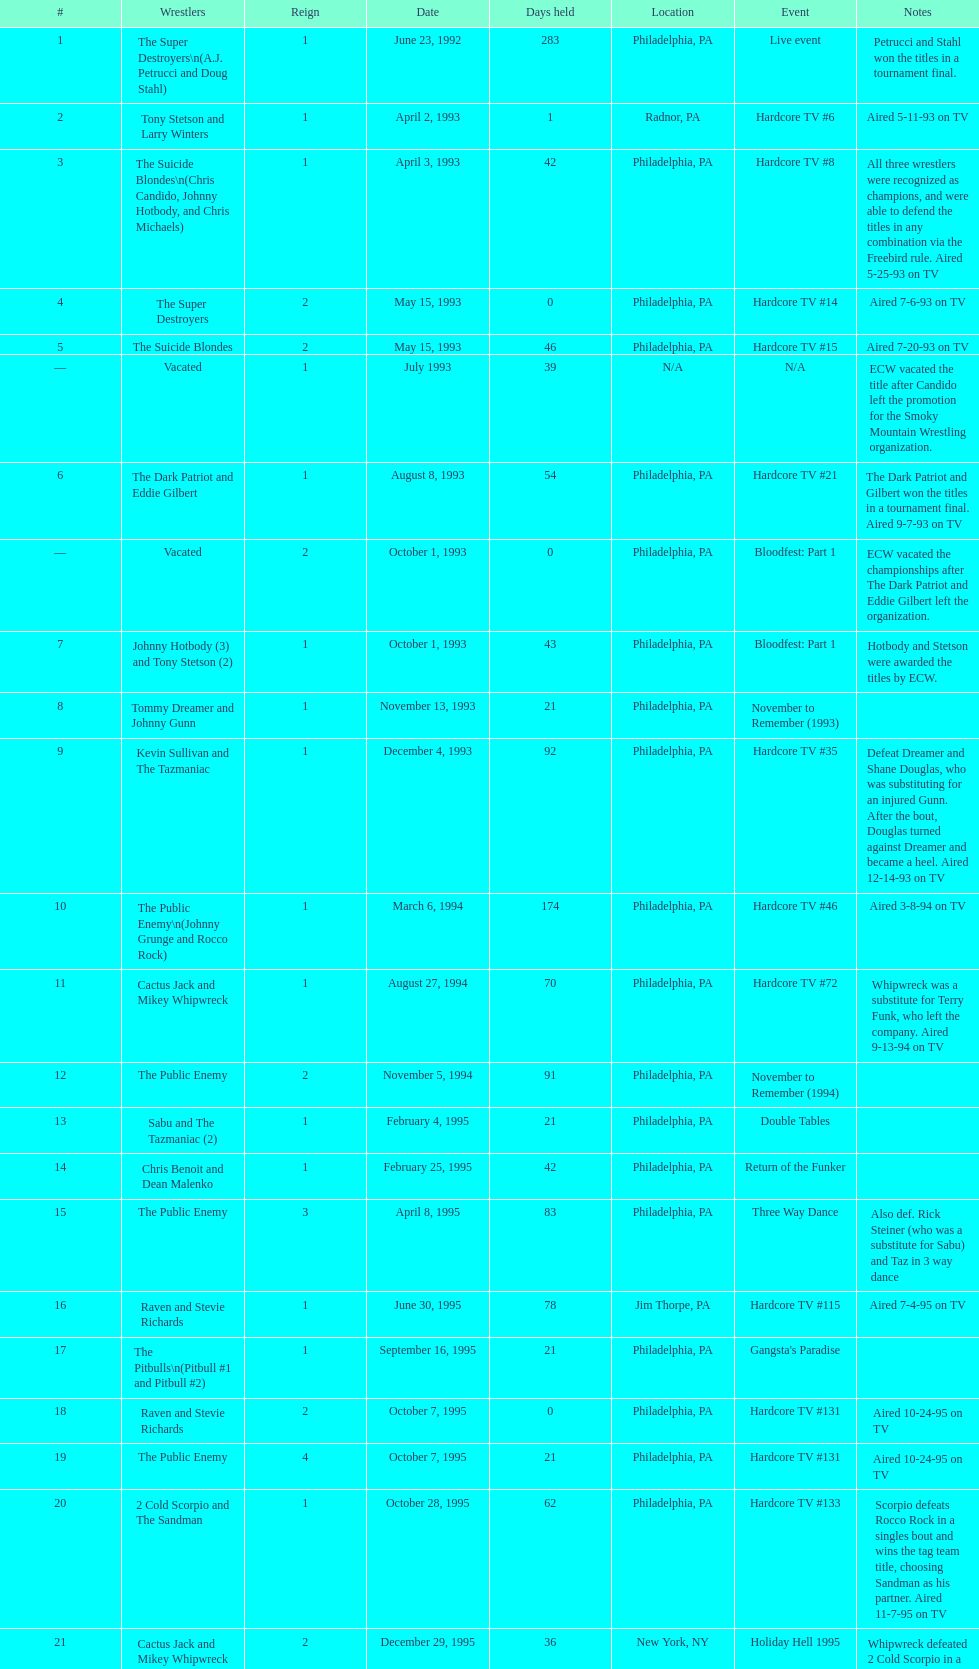Which occurrence precedes hardcore tv episode 14? Hardcore TV #8. Could you parse the entire table as a dict? {'header': ['#', 'Wrestlers', 'Reign', 'Date', 'Days held', 'Location', 'Event', 'Notes'], 'rows': [['1', 'The Super Destroyers\\n(A.J. Petrucci and Doug Stahl)', '1', 'June 23, 1992', '283', 'Philadelphia, PA', 'Live event', 'Petrucci and Stahl won the titles in a tournament final.'], ['2', 'Tony Stetson and Larry Winters', '1', 'April 2, 1993', '1', 'Radnor, PA', 'Hardcore TV #6', 'Aired 5-11-93 on TV'], ['3', 'The Suicide Blondes\\n(Chris Candido, Johnny Hotbody, and Chris Michaels)', '1', 'April 3, 1993', '42', 'Philadelphia, PA', 'Hardcore TV #8', 'All three wrestlers were recognized as champions, and were able to defend the titles in any combination via the Freebird rule. Aired 5-25-93 on TV'], ['4', 'The Super Destroyers', '2', 'May 15, 1993', '0', 'Philadelphia, PA', 'Hardcore TV #14', 'Aired 7-6-93 on TV'], ['5', 'The Suicide Blondes', '2', 'May 15, 1993', '46', 'Philadelphia, PA', 'Hardcore TV #15', 'Aired 7-20-93 on TV'], ['—', 'Vacated', '1', 'July 1993', '39', 'N/A', 'N/A', 'ECW vacated the title after Candido left the promotion for the Smoky Mountain Wrestling organization.'], ['6', 'The Dark Patriot and Eddie Gilbert', '1', 'August 8, 1993', '54', 'Philadelphia, PA', 'Hardcore TV #21', 'The Dark Patriot and Gilbert won the titles in a tournament final. Aired 9-7-93 on TV'], ['—', 'Vacated', '2', 'October 1, 1993', '0', 'Philadelphia, PA', 'Bloodfest: Part 1', 'ECW vacated the championships after The Dark Patriot and Eddie Gilbert left the organization.'], ['7', 'Johnny Hotbody (3) and Tony Stetson (2)', '1', 'October 1, 1993', '43', 'Philadelphia, PA', 'Bloodfest: Part 1', 'Hotbody and Stetson were awarded the titles by ECW.'], ['8', 'Tommy Dreamer and Johnny Gunn', '1', 'November 13, 1993', '21', 'Philadelphia, PA', 'November to Remember (1993)', ''], ['9', 'Kevin Sullivan and The Tazmaniac', '1', 'December 4, 1993', '92', 'Philadelphia, PA', 'Hardcore TV #35', 'Defeat Dreamer and Shane Douglas, who was substituting for an injured Gunn. After the bout, Douglas turned against Dreamer and became a heel. Aired 12-14-93 on TV'], ['10', 'The Public Enemy\\n(Johnny Grunge and Rocco Rock)', '1', 'March 6, 1994', '174', 'Philadelphia, PA', 'Hardcore TV #46', 'Aired 3-8-94 on TV'], ['11', 'Cactus Jack and Mikey Whipwreck', '1', 'August 27, 1994', '70', 'Philadelphia, PA', 'Hardcore TV #72', 'Whipwreck was a substitute for Terry Funk, who left the company. Aired 9-13-94 on TV'], ['12', 'The Public Enemy', '2', 'November 5, 1994', '91', 'Philadelphia, PA', 'November to Remember (1994)', ''], ['13', 'Sabu and The Tazmaniac (2)', '1', 'February 4, 1995', '21', 'Philadelphia, PA', 'Double Tables', ''], ['14', 'Chris Benoit and Dean Malenko', '1', 'February 25, 1995', '42', 'Philadelphia, PA', 'Return of the Funker', ''], ['15', 'The Public Enemy', '3', 'April 8, 1995', '83', 'Philadelphia, PA', 'Three Way Dance', 'Also def. Rick Steiner (who was a substitute for Sabu) and Taz in 3 way dance'], ['16', 'Raven and Stevie Richards', '1', 'June 30, 1995', '78', 'Jim Thorpe, PA', 'Hardcore TV #115', 'Aired 7-4-95 on TV'], ['17', 'The Pitbulls\\n(Pitbull #1 and Pitbull #2)', '1', 'September 16, 1995', '21', 'Philadelphia, PA', "Gangsta's Paradise", ''], ['18', 'Raven and Stevie Richards', '2', 'October 7, 1995', '0', 'Philadelphia, PA', 'Hardcore TV #131', 'Aired 10-24-95 on TV'], ['19', 'The Public Enemy', '4', 'October 7, 1995', '21', 'Philadelphia, PA', 'Hardcore TV #131', 'Aired 10-24-95 on TV'], ['20', '2 Cold Scorpio and The Sandman', '1', 'October 28, 1995', '62', 'Philadelphia, PA', 'Hardcore TV #133', 'Scorpio defeats Rocco Rock in a singles bout and wins the tag team title, choosing Sandman as his partner. Aired 11-7-95 on TV'], ['21', 'Cactus Jack and Mikey Whipwreck', '2', 'December 29, 1995', '36', 'New York, NY', 'Holiday Hell 1995', "Whipwreck defeated 2 Cold Scorpio in a singles match to win both the tag team titles and the ECW World Television Championship; Cactus Jack came out and declared himself to be Mikey's partner after he won the match."], ['22', 'The Eliminators\\n(Kronus and Saturn)', '1', 'February 3, 1996', '182', 'New York, NY', 'Big Apple Blizzard Blast', ''], ['23', 'The Gangstas\\n(Mustapha Saed and New Jack)', '1', 'August 3, 1996', '139', 'Philadelphia, PA', 'Doctor Is In', ''], ['24', 'The Eliminators', '2', 'December 20, 1996', '85', 'Middletown, NY', 'Hardcore TV #193', 'Aired on 12/31/96 on Hardcore TV'], ['25', 'The Dudley Boyz\\n(Buh Buh Ray Dudley and D-Von Dudley)', '1', 'March 15, 1997', '29', 'Philadelphia, PA', 'Hostile City Showdown', 'Aired 3/20/97 on Hardcore TV'], ['26', 'The Eliminators', '3', 'April 13, 1997', '68', 'Philadelphia, PA', 'Barely Legal', ''], ['27', 'The Dudley Boyz', '2', 'June 20, 1997', '29', 'Waltham, MA', 'Hardcore TV #218', 'The Dudley Boyz defeated Kronus in a handicap match as a result of a sidelining injury sustained by Saturn. Aired 6-26-97 on TV'], ['28', 'The Gangstas', '2', 'July 19, 1997', '29', 'Philadelphia, PA', 'Heat Wave 1997/Hardcore TV #222', 'Aired 7-24-97 on TV'], ['29', 'The Dudley Boyz', '3', 'August 17, 1997', '95', 'Fort Lauderdale, FL', 'Hardcore Heaven (1997)', 'The Dudley Boyz won the championship via forfeit as a result of Mustapha Saed leaving the promotion before Hardcore Heaven took place.'], ['30', 'The Gangstanators\\n(Kronus (4) and New Jack (3))', '1', 'September 20, 1997', '28', 'Philadelphia, PA', 'As Good as it Gets', 'Aired 9-27-97 on TV'], ['31', 'Full Blooded Italians\\n(Little Guido and Tracy Smothers)', '1', 'October 18, 1997', '48', 'Philadelphia, PA', 'Hardcore TV #236', 'Aired 11-1-97 on TV'], ['32', 'Doug Furnas and Phil LaFon', '1', 'December 5, 1997', '1', 'Waltham, MA', 'Live event', ''], ['33', 'Chris Candido (3) and Lance Storm', '1', 'December 6, 1997', '203', 'Philadelphia, PA', 'Better than Ever', ''], ['34', 'Sabu (2) and Rob Van Dam', '1', 'June 27, 1998', '119', 'Philadelphia, PA', 'Hardcore TV #271', 'Aired 7-1-98 on TV'], ['35', 'The Dudley Boyz', '4', 'October 24, 1998', '8', 'Cleveland, OH', 'Hardcore TV #288', 'Aired 10-28-98 on TV'], ['36', 'Balls Mahoney and Masato Tanaka', '1', 'November 1, 1998', '5', 'New Orleans, LA', 'November to Remember (1998)', ''], ['37', 'The Dudley Boyz', '5', 'November 6, 1998', '37', 'New York, NY', 'Hardcore TV #290', 'Aired 11-11-98 on TV'], ['38', 'Sabu (3) and Rob Van Dam', '2', 'December 13, 1998', '125', 'Tokyo, Japan', 'ECW/FMW Supershow II', 'Aired 12-16-98 on TV'], ['39', 'The Dudley Boyz', '6', 'April 17, 1999', '92', 'Buffalo, NY', 'Hardcore TV #313', 'D-Von Dudley defeated Van Dam in a singles match to win the championship for his team. Aired 4-23-99 on TV'], ['40', 'Spike Dudley and Balls Mahoney (2)', '1', 'July 18, 1999', '26', 'Dayton, OH', 'Heat Wave (1999)', ''], ['41', 'The Dudley Boyz', '7', 'August 13, 1999', '1', 'Cleveland, OH', 'Hardcore TV #330', 'Aired 8-20-99 on TV'], ['42', 'Spike Dudley and Balls Mahoney (3)', '2', 'August 14, 1999', '12', 'Toledo, OH', 'Hardcore TV #331', 'Aired 8-27-99 on TV'], ['43', 'The Dudley Boyz', '8', 'August 26, 1999', '0', 'New York, NY', 'ECW on TNN#2', 'Aired 9-3-99 on TV'], ['44', 'Tommy Dreamer (2) and Raven (3)', '1', 'August 26, 1999', '136', 'New York, NY', 'ECW on TNN#2', 'Aired 9-3-99 on TV'], ['45', 'Impact Players\\n(Justin Credible and Lance Storm (2))', '1', 'January 9, 2000', '48', 'Birmingham, AL', 'Guilty as Charged (2000)', ''], ['46', 'Tommy Dreamer (3) and Masato Tanaka (2)', '1', 'February 26, 2000', '7', 'Cincinnati, OH', 'Hardcore TV #358', 'Aired 3-7-00 on TV'], ['47', 'Mike Awesome and Raven (4)', '1', 'March 4, 2000', '8', 'Philadelphia, PA', 'ECW on TNN#29', 'Aired 3-10-00 on TV'], ['48', 'Impact Players\\n(Justin Credible and Lance Storm (3))', '2', 'March 12, 2000', '31', 'Danbury, CT', 'Living Dangerously', ''], ['—', 'Vacated', '3', 'April 22, 2000', '125', 'Philadelphia, PA', 'Live event', 'At CyberSlam, Justin Credible threw down the titles to become eligible for the ECW World Heavyweight Championship. Storm later left for World Championship Wrestling. As a result of the circumstances, Credible vacated the championship.'], ['49', 'Yoshihiro Tajiri and Mikey Whipwreck (3)', '1', 'August 25, 2000', '1', 'New York, NY', 'ECW on TNN#55', 'Aired 9-1-00 on TV'], ['50', 'Full Blooded Italians\\n(Little Guido (2) and Tony Mamaluke)', '1', 'August 26, 2000', '99', 'New York, NY', 'ECW on TNN#56', 'Aired 9-8-00 on TV'], ['51', 'Danny Doring and Roadkill', '1', 'December 3, 2000', '122', 'New York, NY', 'Massacre on 34th Street', "Doring and Roadkill's reign was the final one in the title's history."]]} 